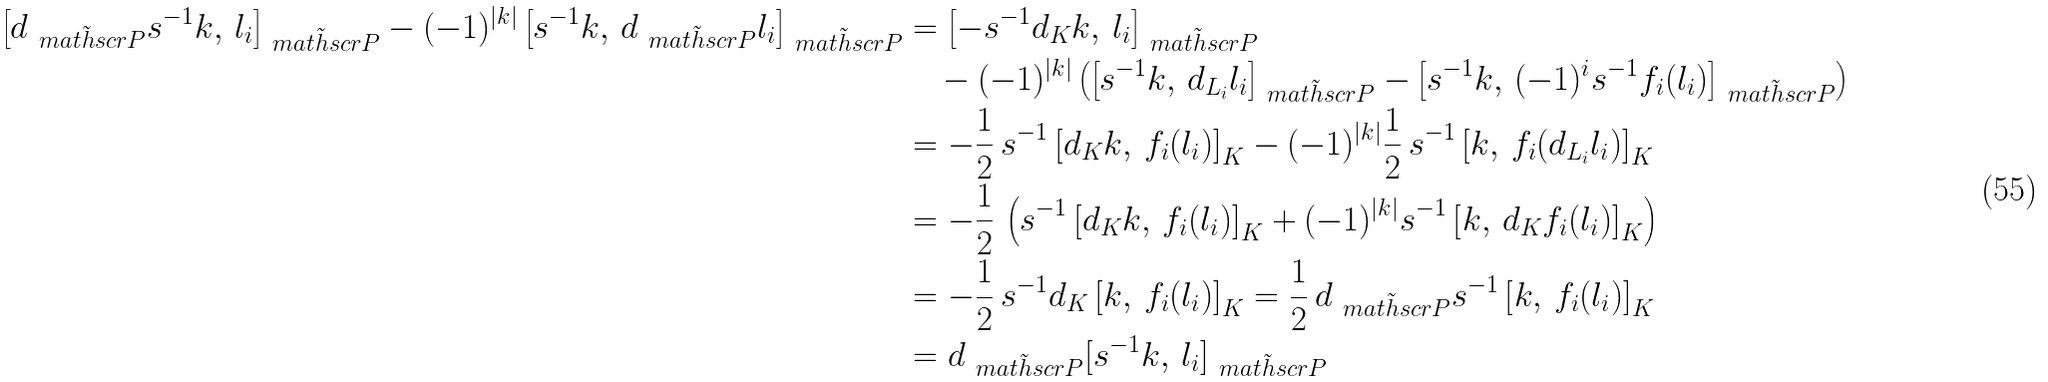<formula> <loc_0><loc_0><loc_500><loc_500>\left [ d _ { \tilde { \ m a t h s c r { P } } } s ^ { - 1 } k , \, l _ { i } \right ] _ { \tilde { \ m a t h s c r { P } } } - ( - 1 ) ^ { | k | } \left [ s ^ { - 1 } k , \, d _ { \tilde { \ m a t h s c r { P } } } l _ { i } \right ] _ { \tilde { \ m a t h s c r { P } } } & = \left [ - s ^ { - 1 } d _ { K } k , \, l _ { i } \right ] _ { \tilde { \ m a t h s c r { P } } } \\ & \quad - ( - 1 ) ^ { | k | } \left ( \left [ s ^ { - 1 } k , \, d _ { L _ { i } } l _ { i } \right ] _ { \tilde { \ m a t h s c r { P } } } - \left [ s ^ { - 1 } k , \, ( - 1 ) ^ { i } s ^ { - 1 } f _ { i } ( l _ { i } ) \right ] _ { \tilde { \ m a t h s c r { P } } } \right ) \\ & = - { \frac { 1 } { 2 } } \, s ^ { - 1 } \left [ d _ { K } k , \, f _ { i } ( l _ { i } ) \right ] _ { K } - ( - 1 ) ^ { | k | } { \frac { 1 } { 2 } } \, s ^ { - 1 } \left [ k , \, f _ { i } ( d _ { L _ { i } } l _ { i } ) \right ] _ { K } \\ & = - { \frac { 1 } { 2 } } \, \left ( s ^ { - 1 } \left [ d _ { K } k , \, f _ { i } ( l _ { i } ) \right ] _ { K } + ( - 1 ) ^ { | k | } s ^ { - 1 } \left [ k , \, d _ { K } f _ { i } ( l _ { i } ) \right ] _ { K } \right ) \\ & = - { \frac { 1 } { 2 } } \, s ^ { - 1 } d _ { K } \left [ k , \, f _ { i } ( l _ { i } ) \right ] _ { K } = { \frac { 1 } { 2 } } \, d _ { \tilde { \ m a t h s c r { P } } } s ^ { - 1 } \left [ k , \, f _ { i } ( l _ { i } ) \right ] _ { K } \\ & = d _ { \tilde { \ m a t h s c r { P } } } [ s ^ { - 1 } k , \, l _ { i } ] _ { \tilde { \ m a t h s c r { P } } }</formula> 